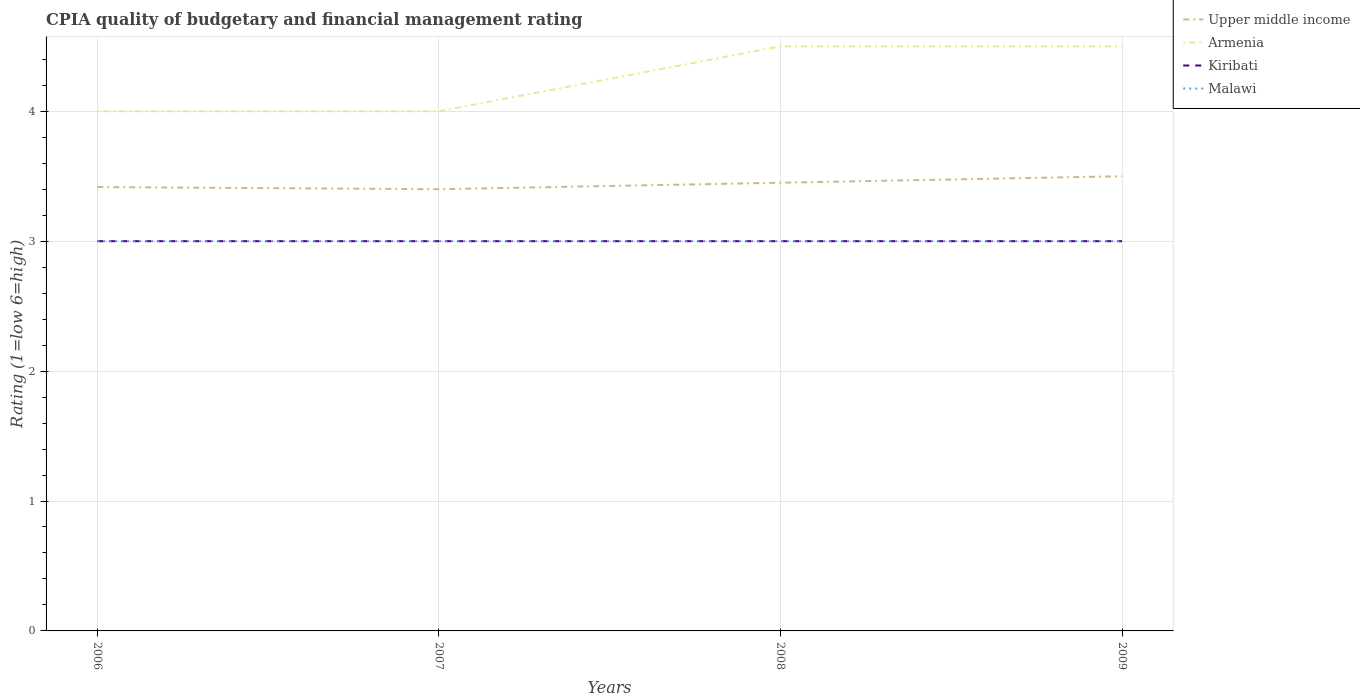How many different coloured lines are there?
Provide a succinct answer. 4. Is the number of lines equal to the number of legend labels?
Offer a terse response. Yes. Across all years, what is the maximum CPIA rating in Kiribati?
Your answer should be compact. 3. In which year was the CPIA rating in Armenia maximum?
Your answer should be very brief. 2006. What is the total CPIA rating in Malawi in the graph?
Offer a terse response. 0. What is the difference between the highest and the second highest CPIA rating in Kiribati?
Make the answer very short. 0. What is the difference between the highest and the lowest CPIA rating in Armenia?
Ensure brevity in your answer.  2. Are the values on the major ticks of Y-axis written in scientific E-notation?
Provide a succinct answer. No. What is the title of the graph?
Ensure brevity in your answer.  CPIA quality of budgetary and financial management rating. Does "Kazakhstan" appear as one of the legend labels in the graph?
Your response must be concise. No. What is the label or title of the Y-axis?
Offer a terse response. Rating (1=low 6=high). What is the Rating (1=low 6=high) of Upper middle income in 2006?
Offer a terse response. 3.42. What is the Rating (1=low 6=high) in Kiribati in 2006?
Offer a terse response. 3. What is the Rating (1=low 6=high) in Upper middle income in 2007?
Provide a short and direct response. 3.4. What is the Rating (1=low 6=high) of Kiribati in 2007?
Your response must be concise. 3. What is the Rating (1=low 6=high) in Upper middle income in 2008?
Your response must be concise. 3.45. What is the Rating (1=low 6=high) of Armenia in 2008?
Provide a succinct answer. 4.5. What is the Rating (1=low 6=high) of Upper middle income in 2009?
Offer a very short reply. 3.5. What is the Rating (1=low 6=high) of Malawi in 2009?
Make the answer very short. 3. Across all years, what is the maximum Rating (1=low 6=high) in Upper middle income?
Make the answer very short. 3.5. Across all years, what is the minimum Rating (1=low 6=high) of Upper middle income?
Give a very brief answer. 3.4. Across all years, what is the minimum Rating (1=low 6=high) in Armenia?
Your answer should be very brief. 4. Across all years, what is the minimum Rating (1=low 6=high) in Malawi?
Your answer should be compact. 3. What is the total Rating (1=low 6=high) in Upper middle income in the graph?
Provide a short and direct response. 13.77. What is the total Rating (1=low 6=high) of Armenia in the graph?
Provide a succinct answer. 17. What is the total Rating (1=low 6=high) in Kiribati in the graph?
Your answer should be very brief. 12. What is the difference between the Rating (1=low 6=high) of Upper middle income in 2006 and that in 2007?
Keep it short and to the point. 0.02. What is the difference between the Rating (1=low 6=high) in Armenia in 2006 and that in 2007?
Give a very brief answer. 0. What is the difference between the Rating (1=low 6=high) in Malawi in 2006 and that in 2007?
Give a very brief answer. 0. What is the difference between the Rating (1=low 6=high) in Upper middle income in 2006 and that in 2008?
Ensure brevity in your answer.  -0.03. What is the difference between the Rating (1=low 6=high) of Armenia in 2006 and that in 2008?
Offer a terse response. -0.5. What is the difference between the Rating (1=low 6=high) in Malawi in 2006 and that in 2008?
Provide a short and direct response. 0. What is the difference between the Rating (1=low 6=high) in Upper middle income in 2006 and that in 2009?
Your response must be concise. -0.08. What is the difference between the Rating (1=low 6=high) in Armenia in 2006 and that in 2009?
Give a very brief answer. -0.5. What is the difference between the Rating (1=low 6=high) of Kiribati in 2007 and that in 2008?
Ensure brevity in your answer.  0. What is the difference between the Rating (1=low 6=high) in Malawi in 2007 and that in 2008?
Offer a very short reply. 0. What is the difference between the Rating (1=low 6=high) in Upper middle income in 2007 and that in 2009?
Provide a short and direct response. -0.1. What is the difference between the Rating (1=low 6=high) of Malawi in 2007 and that in 2009?
Provide a short and direct response. 0. What is the difference between the Rating (1=low 6=high) in Upper middle income in 2008 and that in 2009?
Offer a very short reply. -0.05. What is the difference between the Rating (1=low 6=high) in Malawi in 2008 and that in 2009?
Offer a very short reply. 0. What is the difference between the Rating (1=low 6=high) in Upper middle income in 2006 and the Rating (1=low 6=high) in Armenia in 2007?
Ensure brevity in your answer.  -0.58. What is the difference between the Rating (1=low 6=high) in Upper middle income in 2006 and the Rating (1=low 6=high) in Kiribati in 2007?
Your answer should be very brief. 0.42. What is the difference between the Rating (1=low 6=high) of Upper middle income in 2006 and the Rating (1=low 6=high) of Malawi in 2007?
Your answer should be very brief. 0.42. What is the difference between the Rating (1=low 6=high) of Upper middle income in 2006 and the Rating (1=low 6=high) of Armenia in 2008?
Ensure brevity in your answer.  -1.08. What is the difference between the Rating (1=low 6=high) in Upper middle income in 2006 and the Rating (1=low 6=high) in Kiribati in 2008?
Keep it short and to the point. 0.42. What is the difference between the Rating (1=low 6=high) of Upper middle income in 2006 and the Rating (1=low 6=high) of Malawi in 2008?
Provide a short and direct response. 0.42. What is the difference between the Rating (1=low 6=high) of Armenia in 2006 and the Rating (1=low 6=high) of Kiribati in 2008?
Ensure brevity in your answer.  1. What is the difference between the Rating (1=low 6=high) of Upper middle income in 2006 and the Rating (1=low 6=high) of Armenia in 2009?
Your response must be concise. -1.08. What is the difference between the Rating (1=low 6=high) of Upper middle income in 2006 and the Rating (1=low 6=high) of Kiribati in 2009?
Give a very brief answer. 0.42. What is the difference between the Rating (1=low 6=high) in Upper middle income in 2006 and the Rating (1=low 6=high) in Malawi in 2009?
Offer a very short reply. 0.42. What is the difference between the Rating (1=low 6=high) in Armenia in 2006 and the Rating (1=low 6=high) in Kiribati in 2009?
Provide a short and direct response. 1. What is the difference between the Rating (1=low 6=high) of Upper middle income in 2007 and the Rating (1=low 6=high) of Armenia in 2008?
Provide a succinct answer. -1.1. What is the difference between the Rating (1=low 6=high) in Upper middle income in 2007 and the Rating (1=low 6=high) in Malawi in 2008?
Provide a short and direct response. 0.4. What is the difference between the Rating (1=low 6=high) of Armenia in 2007 and the Rating (1=low 6=high) of Malawi in 2008?
Offer a terse response. 1. What is the difference between the Rating (1=low 6=high) of Kiribati in 2007 and the Rating (1=low 6=high) of Malawi in 2008?
Your answer should be very brief. 0. What is the difference between the Rating (1=low 6=high) in Upper middle income in 2007 and the Rating (1=low 6=high) in Malawi in 2009?
Ensure brevity in your answer.  0.4. What is the difference between the Rating (1=low 6=high) in Armenia in 2007 and the Rating (1=low 6=high) in Kiribati in 2009?
Your answer should be very brief. 1. What is the difference between the Rating (1=low 6=high) in Armenia in 2007 and the Rating (1=low 6=high) in Malawi in 2009?
Your answer should be compact. 1. What is the difference between the Rating (1=low 6=high) of Upper middle income in 2008 and the Rating (1=low 6=high) of Armenia in 2009?
Your answer should be very brief. -1.05. What is the difference between the Rating (1=low 6=high) in Upper middle income in 2008 and the Rating (1=low 6=high) in Kiribati in 2009?
Make the answer very short. 0.45. What is the difference between the Rating (1=low 6=high) of Upper middle income in 2008 and the Rating (1=low 6=high) of Malawi in 2009?
Provide a short and direct response. 0.45. What is the difference between the Rating (1=low 6=high) in Armenia in 2008 and the Rating (1=low 6=high) in Kiribati in 2009?
Give a very brief answer. 1.5. What is the difference between the Rating (1=low 6=high) in Armenia in 2008 and the Rating (1=low 6=high) in Malawi in 2009?
Your answer should be very brief. 1.5. What is the average Rating (1=low 6=high) in Upper middle income per year?
Your answer should be compact. 3.44. What is the average Rating (1=low 6=high) of Armenia per year?
Offer a very short reply. 4.25. In the year 2006, what is the difference between the Rating (1=low 6=high) in Upper middle income and Rating (1=low 6=high) in Armenia?
Give a very brief answer. -0.58. In the year 2006, what is the difference between the Rating (1=low 6=high) in Upper middle income and Rating (1=low 6=high) in Kiribati?
Provide a short and direct response. 0.42. In the year 2006, what is the difference between the Rating (1=low 6=high) of Upper middle income and Rating (1=low 6=high) of Malawi?
Your answer should be compact. 0.42. In the year 2006, what is the difference between the Rating (1=low 6=high) of Armenia and Rating (1=low 6=high) of Malawi?
Make the answer very short. 1. In the year 2007, what is the difference between the Rating (1=low 6=high) in Upper middle income and Rating (1=low 6=high) in Armenia?
Your answer should be very brief. -0.6. In the year 2007, what is the difference between the Rating (1=low 6=high) in Upper middle income and Rating (1=low 6=high) in Kiribati?
Keep it short and to the point. 0.4. In the year 2007, what is the difference between the Rating (1=low 6=high) of Upper middle income and Rating (1=low 6=high) of Malawi?
Ensure brevity in your answer.  0.4. In the year 2007, what is the difference between the Rating (1=low 6=high) of Armenia and Rating (1=low 6=high) of Kiribati?
Your response must be concise. 1. In the year 2007, what is the difference between the Rating (1=low 6=high) in Kiribati and Rating (1=low 6=high) in Malawi?
Make the answer very short. 0. In the year 2008, what is the difference between the Rating (1=low 6=high) in Upper middle income and Rating (1=low 6=high) in Armenia?
Your answer should be very brief. -1.05. In the year 2008, what is the difference between the Rating (1=low 6=high) in Upper middle income and Rating (1=low 6=high) in Kiribati?
Give a very brief answer. 0.45. In the year 2008, what is the difference between the Rating (1=low 6=high) in Upper middle income and Rating (1=low 6=high) in Malawi?
Keep it short and to the point. 0.45. In the year 2008, what is the difference between the Rating (1=low 6=high) of Armenia and Rating (1=low 6=high) of Kiribati?
Ensure brevity in your answer.  1.5. In the year 2008, what is the difference between the Rating (1=low 6=high) of Armenia and Rating (1=low 6=high) of Malawi?
Offer a terse response. 1.5. In the year 2009, what is the difference between the Rating (1=low 6=high) of Upper middle income and Rating (1=low 6=high) of Malawi?
Your answer should be very brief. 0.5. In the year 2009, what is the difference between the Rating (1=low 6=high) in Armenia and Rating (1=low 6=high) in Kiribati?
Offer a terse response. 1.5. In the year 2009, what is the difference between the Rating (1=low 6=high) in Kiribati and Rating (1=low 6=high) in Malawi?
Keep it short and to the point. 0. What is the ratio of the Rating (1=low 6=high) in Upper middle income in 2006 to that in 2007?
Your response must be concise. 1. What is the ratio of the Rating (1=low 6=high) of Armenia in 2006 to that in 2007?
Give a very brief answer. 1. What is the ratio of the Rating (1=low 6=high) in Upper middle income in 2006 to that in 2008?
Give a very brief answer. 0.99. What is the ratio of the Rating (1=low 6=high) of Armenia in 2006 to that in 2008?
Offer a terse response. 0.89. What is the ratio of the Rating (1=low 6=high) of Upper middle income in 2006 to that in 2009?
Make the answer very short. 0.98. What is the ratio of the Rating (1=low 6=high) in Armenia in 2006 to that in 2009?
Offer a very short reply. 0.89. What is the ratio of the Rating (1=low 6=high) of Kiribati in 2006 to that in 2009?
Your answer should be very brief. 1. What is the ratio of the Rating (1=low 6=high) in Malawi in 2006 to that in 2009?
Keep it short and to the point. 1. What is the ratio of the Rating (1=low 6=high) in Upper middle income in 2007 to that in 2008?
Offer a terse response. 0.99. What is the ratio of the Rating (1=low 6=high) in Kiribati in 2007 to that in 2008?
Your answer should be compact. 1. What is the ratio of the Rating (1=low 6=high) in Malawi in 2007 to that in 2008?
Keep it short and to the point. 1. What is the ratio of the Rating (1=low 6=high) of Upper middle income in 2007 to that in 2009?
Your answer should be very brief. 0.97. What is the ratio of the Rating (1=low 6=high) in Malawi in 2007 to that in 2009?
Provide a short and direct response. 1. What is the ratio of the Rating (1=low 6=high) of Upper middle income in 2008 to that in 2009?
Your answer should be compact. 0.99. What is the ratio of the Rating (1=low 6=high) in Armenia in 2008 to that in 2009?
Your answer should be compact. 1. What is the ratio of the Rating (1=low 6=high) of Malawi in 2008 to that in 2009?
Make the answer very short. 1. What is the difference between the highest and the second highest Rating (1=low 6=high) of Malawi?
Provide a succinct answer. 0. What is the difference between the highest and the lowest Rating (1=low 6=high) in Upper middle income?
Provide a short and direct response. 0.1. What is the difference between the highest and the lowest Rating (1=low 6=high) of Armenia?
Offer a very short reply. 0.5. What is the difference between the highest and the lowest Rating (1=low 6=high) of Malawi?
Make the answer very short. 0. 